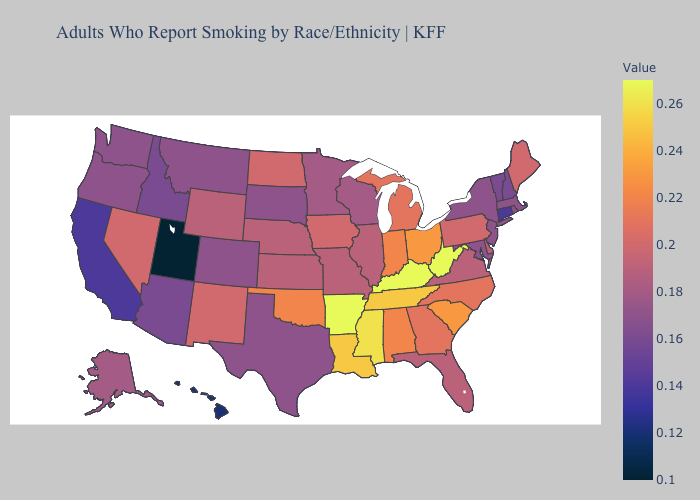Does Oklahoma have a higher value than Nebraska?
Be succinct. Yes. Among the states that border Nevada , does Utah have the lowest value?
Answer briefly. Yes. Does Ohio have the highest value in the MidWest?
Short answer required. Yes. Among the states that border Massachusetts , which have the lowest value?
Concise answer only. Connecticut. 